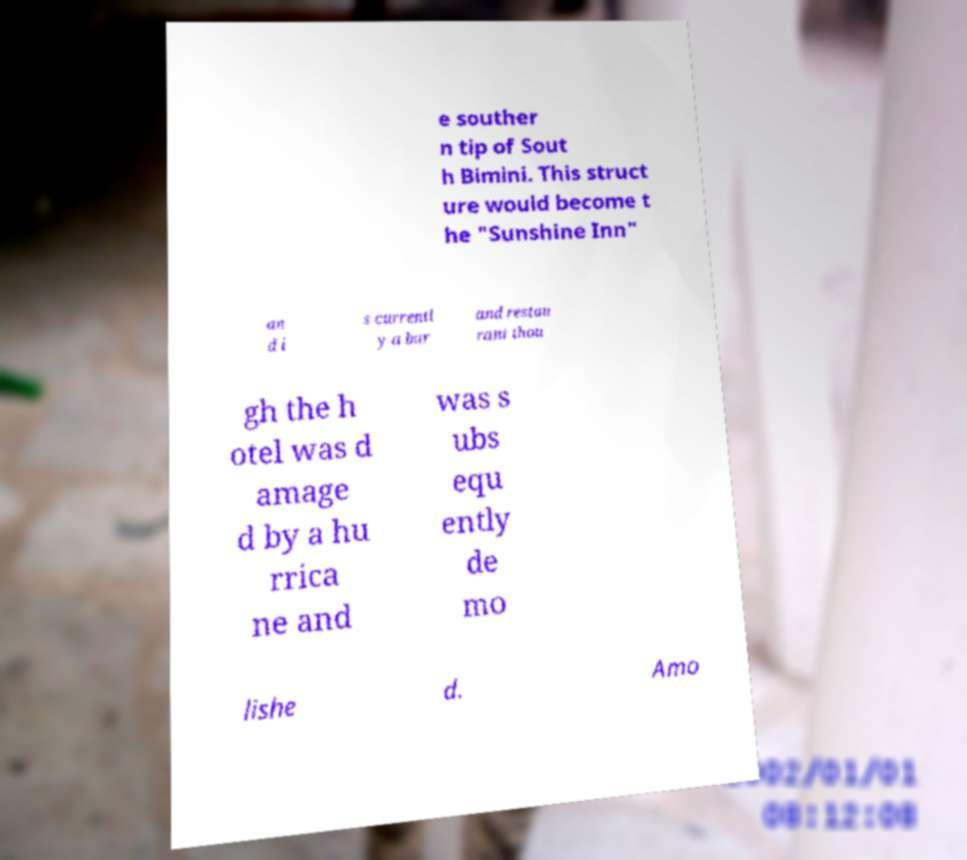Could you extract and type out the text from this image? e souther n tip of Sout h Bimini. This struct ure would become t he "Sunshine Inn" an d i s currentl y a bar and restau rant thou gh the h otel was d amage d by a hu rrica ne and was s ubs equ ently de mo lishe d. Amo 